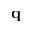Convert formula to latex. <formula><loc_0><loc_0><loc_500><loc_500>{ \mathbf q }</formula> 